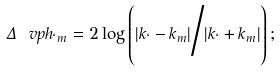<formula> <loc_0><loc_0><loc_500><loc_500>\Delta \ v p h _ { \ell m } = 2 \log \left ( { | k _ { \ell } - k _ { m } | } \Big / { | k _ { \ell } + k _ { m } | } \right ) ;</formula> 